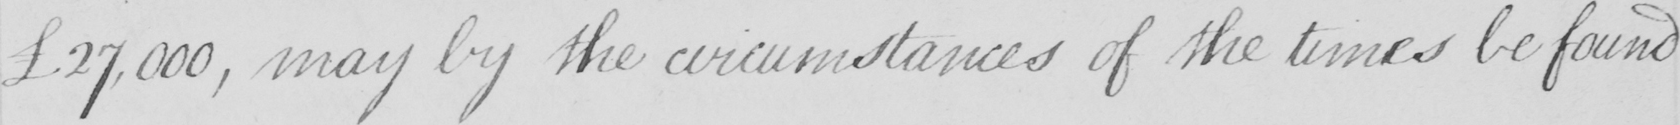What is written in this line of handwriting? £27,000 , may by the circumstances of the times be found 